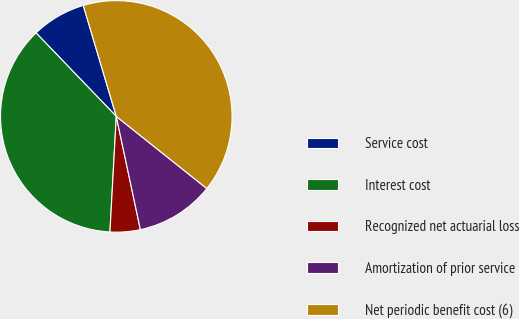Convert chart. <chart><loc_0><loc_0><loc_500><loc_500><pie_chart><fcel>Service cost<fcel>Interest cost<fcel>Recognized net actuarial loss<fcel>Amortization of prior service<fcel>Net periodic benefit cost (6)<nl><fcel>7.58%<fcel>36.94%<fcel>4.21%<fcel>10.95%<fcel>40.31%<nl></chart> 